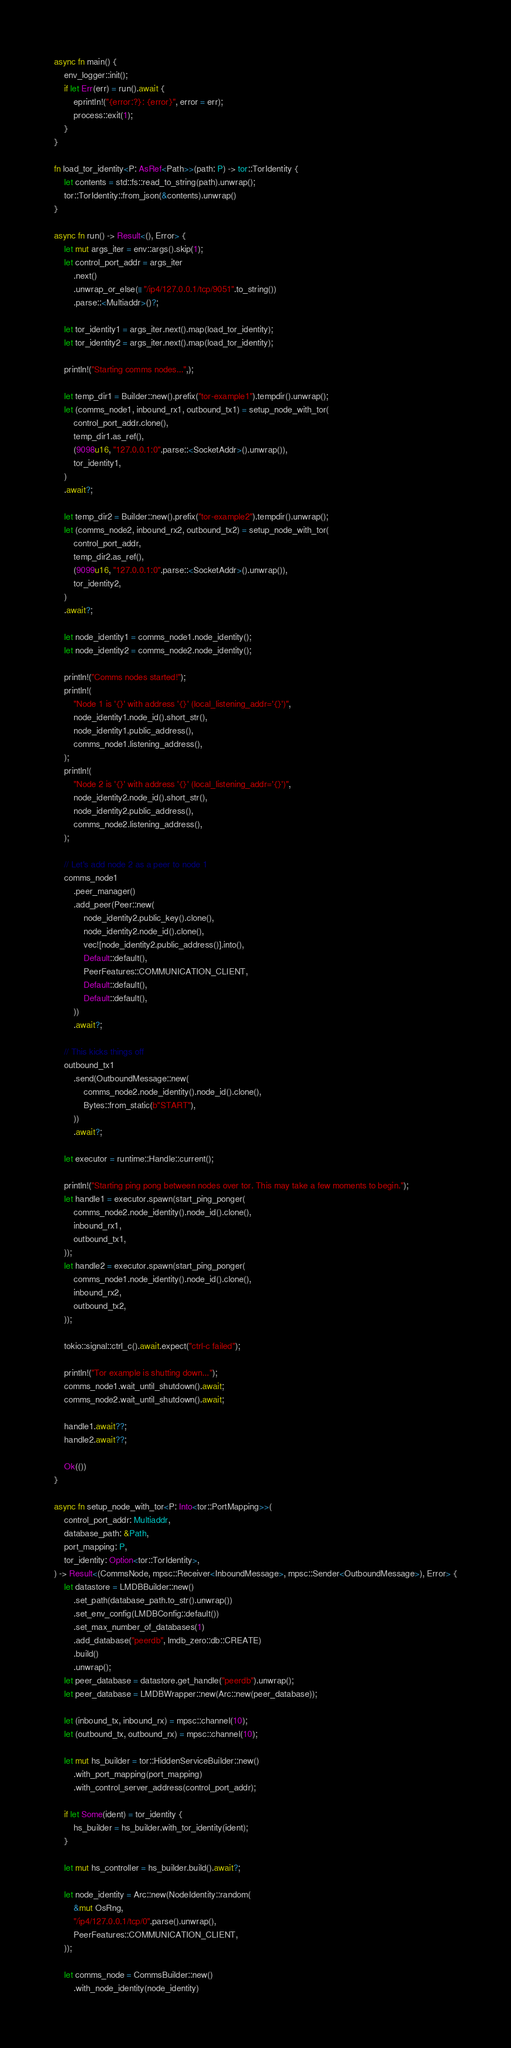<code> <loc_0><loc_0><loc_500><loc_500><_Rust_>async fn main() {
    env_logger::init();
    if let Err(err) = run().await {
        eprintln!("{error:?}: {error}", error = err);
        process::exit(1);
    }
}

fn load_tor_identity<P: AsRef<Path>>(path: P) -> tor::TorIdentity {
    let contents = std::fs::read_to_string(path).unwrap();
    tor::TorIdentity::from_json(&contents).unwrap()
}

async fn run() -> Result<(), Error> {
    let mut args_iter = env::args().skip(1);
    let control_port_addr = args_iter
        .next()
        .unwrap_or_else(|| "/ip4/127.0.0.1/tcp/9051".to_string())
        .parse::<Multiaddr>()?;

    let tor_identity1 = args_iter.next().map(load_tor_identity);
    let tor_identity2 = args_iter.next().map(load_tor_identity);

    println!("Starting comms nodes...",);

    let temp_dir1 = Builder::new().prefix("tor-example1").tempdir().unwrap();
    let (comms_node1, inbound_rx1, outbound_tx1) = setup_node_with_tor(
        control_port_addr.clone(),
        temp_dir1.as_ref(),
        (9098u16, "127.0.0.1:0".parse::<SocketAddr>().unwrap()),
        tor_identity1,
    )
    .await?;

    let temp_dir2 = Builder::new().prefix("tor-example2").tempdir().unwrap();
    let (comms_node2, inbound_rx2, outbound_tx2) = setup_node_with_tor(
        control_port_addr,
        temp_dir2.as_ref(),
        (9099u16, "127.0.0.1:0".parse::<SocketAddr>().unwrap()),
        tor_identity2,
    )
    .await?;

    let node_identity1 = comms_node1.node_identity();
    let node_identity2 = comms_node2.node_identity();

    println!("Comms nodes started!");
    println!(
        "Node 1 is '{}' with address '{}' (local_listening_addr='{}')",
        node_identity1.node_id().short_str(),
        node_identity1.public_address(),
        comms_node1.listening_address(),
    );
    println!(
        "Node 2 is '{}' with address '{}' (local_listening_addr='{}')",
        node_identity2.node_id().short_str(),
        node_identity2.public_address(),
        comms_node2.listening_address(),
    );

    // Let's add node 2 as a peer to node 1
    comms_node1
        .peer_manager()
        .add_peer(Peer::new(
            node_identity2.public_key().clone(),
            node_identity2.node_id().clone(),
            vec![node_identity2.public_address()].into(),
            Default::default(),
            PeerFeatures::COMMUNICATION_CLIENT,
            Default::default(),
            Default::default(),
        ))
        .await?;

    // This kicks things off
    outbound_tx1
        .send(OutboundMessage::new(
            comms_node2.node_identity().node_id().clone(),
            Bytes::from_static(b"START"),
        ))
        .await?;

    let executor = runtime::Handle::current();

    println!("Starting ping pong between nodes over tor. This may take a few moments to begin.");
    let handle1 = executor.spawn(start_ping_ponger(
        comms_node2.node_identity().node_id().clone(),
        inbound_rx1,
        outbound_tx1,
    ));
    let handle2 = executor.spawn(start_ping_ponger(
        comms_node1.node_identity().node_id().clone(),
        inbound_rx2,
        outbound_tx2,
    ));

    tokio::signal::ctrl_c().await.expect("ctrl-c failed");

    println!("Tor example is shutting down...");
    comms_node1.wait_until_shutdown().await;
    comms_node2.wait_until_shutdown().await;

    handle1.await??;
    handle2.await??;

    Ok(())
}

async fn setup_node_with_tor<P: Into<tor::PortMapping>>(
    control_port_addr: Multiaddr,
    database_path: &Path,
    port_mapping: P,
    tor_identity: Option<tor::TorIdentity>,
) -> Result<(CommsNode, mpsc::Receiver<InboundMessage>, mpsc::Sender<OutboundMessage>), Error> {
    let datastore = LMDBBuilder::new()
        .set_path(database_path.to_str().unwrap())
        .set_env_config(LMDBConfig::default())
        .set_max_number_of_databases(1)
        .add_database("peerdb", lmdb_zero::db::CREATE)
        .build()
        .unwrap();
    let peer_database = datastore.get_handle("peerdb").unwrap();
    let peer_database = LMDBWrapper::new(Arc::new(peer_database));

    let (inbound_tx, inbound_rx) = mpsc::channel(10);
    let (outbound_tx, outbound_rx) = mpsc::channel(10);

    let mut hs_builder = tor::HiddenServiceBuilder::new()
        .with_port_mapping(port_mapping)
        .with_control_server_address(control_port_addr);

    if let Some(ident) = tor_identity {
        hs_builder = hs_builder.with_tor_identity(ident);
    }

    let mut hs_controller = hs_builder.build().await?;

    let node_identity = Arc::new(NodeIdentity::random(
        &mut OsRng,
        "/ip4/127.0.0.1/tcp/0".parse().unwrap(),
        PeerFeatures::COMMUNICATION_CLIENT,
    ));

    let comms_node = CommsBuilder::new()
        .with_node_identity(node_identity)</code> 